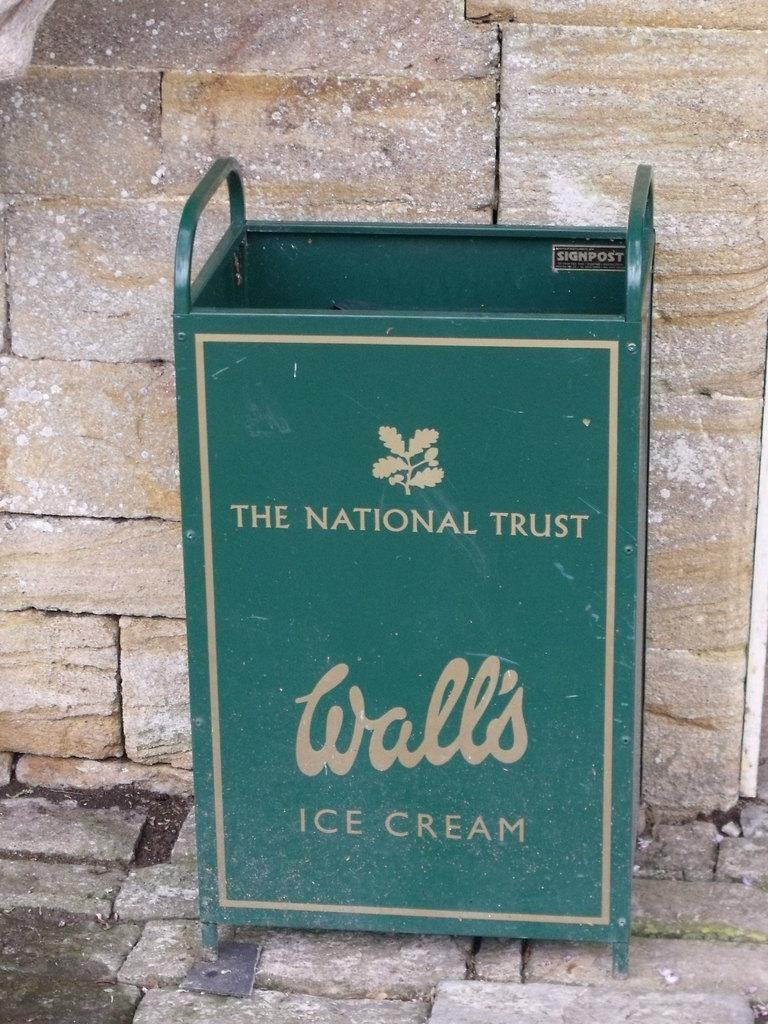<image>
Write a terse but informative summary of the picture. A green trash receptacle on the side of a building says Wall's ice cream. 